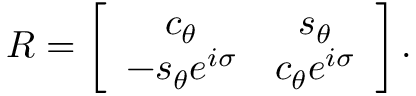<formula> <loc_0><loc_0><loc_500><loc_500>R = \left [ \begin{array} { c c } { { c _ { \theta } } } & { { s _ { \theta } } } \\ { { - s _ { \theta } e ^ { i \sigma } } } & { { c _ { \theta } e ^ { i \sigma } } } \end{array} \right ] .</formula> 